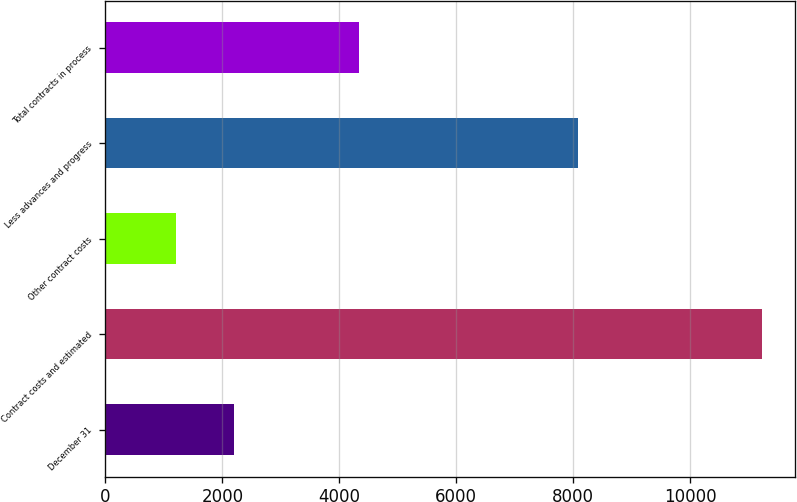Convert chart. <chart><loc_0><loc_0><loc_500><loc_500><bar_chart><fcel>December 31<fcel>Contract costs and estimated<fcel>Other contract costs<fcel>Less advances and progress<fcel>Total contracts in process<nl><fcel>2202.4<fcel>11224<fcel>1200<fcel>8087<fcel>4337<nl></chart> 